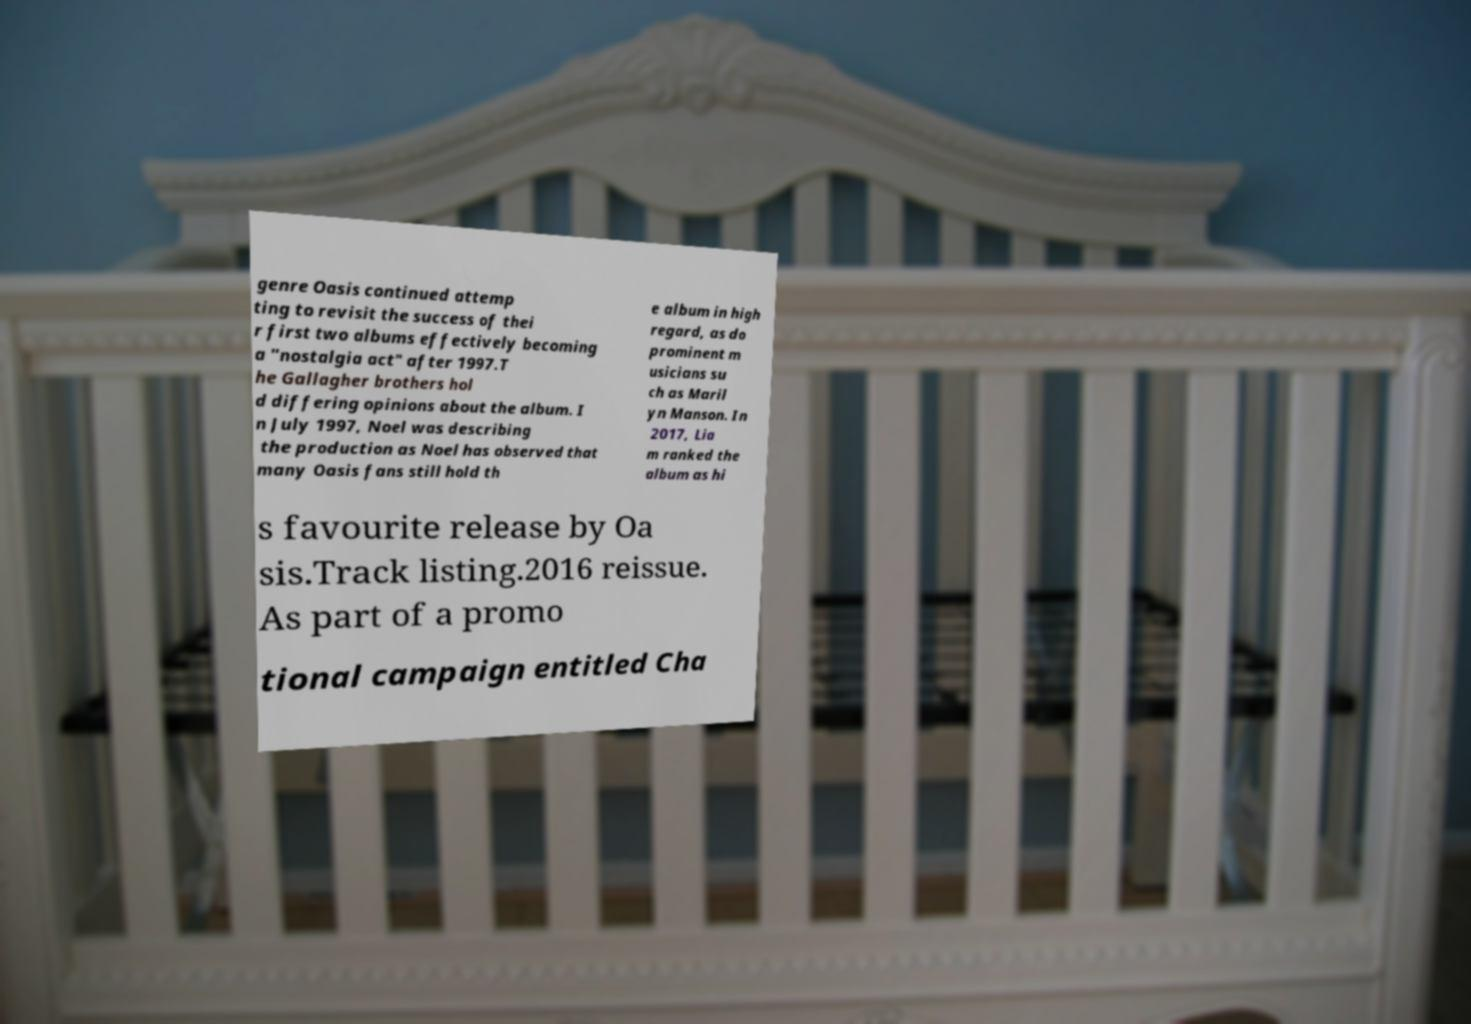For documentation purposes, I need the text within this image transcribed. Could you provide that? genre Oasis continued attemp ting to revisit the success of thei r first two albums effectively becoming a "nostalgia act" after 1997.T he Gallagher brothers hol d differing opinions about the album. I n July 1997, Noel was describing the production as Noel has observed that many Oasis fans still hold th e album in high regard, as do prominent m usicians su ch as Maril yn Manson. In 2017, Lia m ranked the album as hi s favourite release by Oa sis.Track listing.2016 reissue. As part of a promo tional campaign entitled Cha 